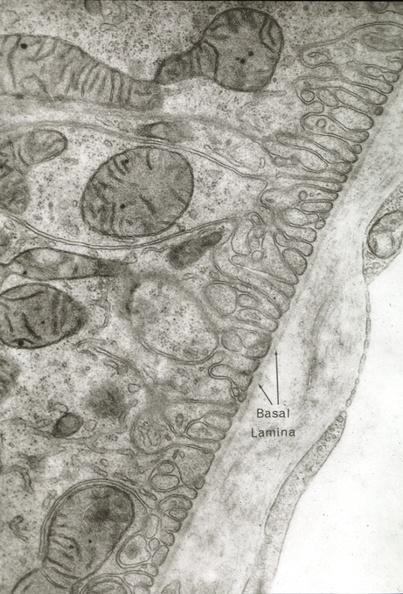s cardiovascular present?
Answer the question using a single word or phrase. Yes 